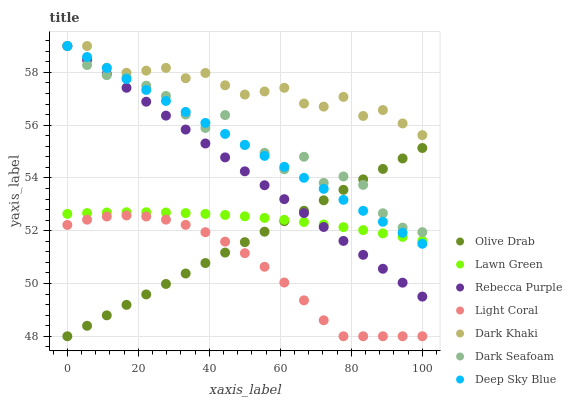Does Light Coral have the minimum area under the curve?
Answer yes or no. Yes. Does Dark Khaki have the maximum area under the curve?
Answer yes or no. Yes. Does Dark Seafoam have the minimum area under the curve?
Answer yes or no. No. Does Dark Seafoam have the maximum area under the curve?
Answer yes or no. No. Is Rebecca Purple the smoothest?
Answer yes or no. Yes. Is Dark Seafoam the roughest?
Answer yes or no. Yes. Is Light Coral the smoothest?
Answer yes or no. No. Is Light Coral the roughest?
Answer yes or no. No. Does Light Coral have the lowest value?
Answer yes or no. Yes. Does Dark Seafoam have the lowest value?
Answer yes or no. No. Does Rebecca Purple have the highest value?
Answer yes or no. Yes. Does Light Coral have the highest value?
Answer yes or no. No. Is Lawn Green less than Dark Seafoam?
Answer yes or no. Yes. Is Dark Khaki greater than Olive Drab?
Answer yes or no. Yes. Does Dark Seafoam intersect Olive Drab?
Answer yes or no. Yes. Is Dark Seafoam less than Olive Drab?
Answer yes or no. No. Is Dark Seafoam greater than Olive Drab?
Answer yes or no. No. Does Lawn Green intersect Dark Seafoam?
Answer yes or no. No. 